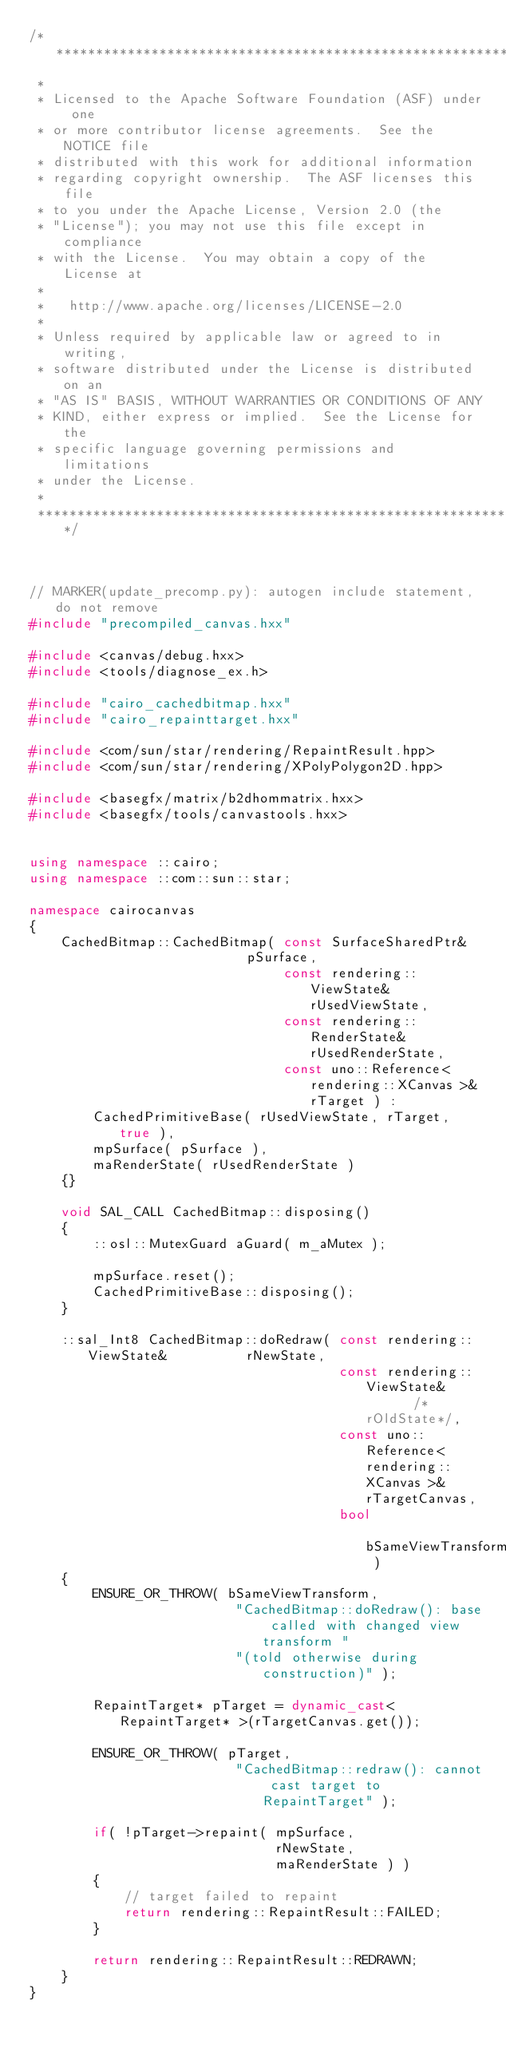Convert code to text. <code><loc_0><loc_0><loc_500><loc_500><_C++_>/**************************************************************
 * 
 * Licensed to the Apache Software Foundation (ASF) under one
 * or more contributor license agreements.  See the NOTICE file
 * distributed with this work for additional information
 * regarding copyright ownership.  The ASF licenses this file
 * to you under the Apache License, Version 2.0 (the
 * "License"); you may not use this file except in compliance
 * with the License.  You may obtain a copy of the License at
 * 
 *   http://www.apache.org/licenses/LICENSE-2.0
 * 
 * Unless required by applicable law or agreed to in writing,
 * software distributed under the License is distributed on an
 * "AS IS" BASIS, WITHOUT WARRANTIES OR CONDITIONS OF ANY
 * KIND, either express or implied.  See the License for the
 * specific language governing permissions and limitations
 * under the License.
 * 
 *************************************************************/



// MARKER(update_precomp.py): autogen include statement, do not remove
#include "precompiled_canvas.hxx"

#include <canvas/debug.hxx>
#include <tools/diagnose_ex.h>

#include "cairo_cachedbitmap.hxx"
#include "cairo_repainttarget.hxx"

#include <com/sun/star/rendering/RepaintResult.hpp>
#include <com/sun/star/rendering/XPolyPolygon2D.hpp>

#include <basegfx/matrix/b2dhommatrix.hxx>
#include <basegfx/tools/canvastools.hxx>


using namespace ::cairo;
using namespace ::com::sun::star;

namespace cairocanvas
{
    CachedBitmap::CachedBitmap( const SurfaceSharedPtr&                     pSurface,
                                const rendering::ViewState&	  				rUsedViewState,
                                const rendering::RenderState&	  			rUsedRenderState,
                                const uno::Reference< rendering::XCanvas >& rTarget ) :
        CachedPrimitiveBase( rUsedViewState, rTarget, true ),
        mpSurface( pSurface ),
        maRenderState( rUsedRenderState )
    {}

    void SAL_CALL CachedBitmap::disposing()
    {
        ::osl::MutexGuard aGuard( m_aMutex );

        mpSurface.reset();
        CachedPrimitiveBase::disposing();
    }

    ::sal_Int8 CachedBitmap::doRedraw( const rendering::ViewState&					rNewState,
                                       const rendering::ViewState&					/*rOldState*/,
                                       const uno::Reference< rendering::XCanvas >& 	rTargetCanvas,
                                       bool											bSameViewTransform )
    {
        ENSURE_OR_THROW( bSameViewTransform,
                          "CachedBitmap::doRedraw(): base called with changed view transform "
                          "(told otherwise during construction)" );

        RepaintTarget* pTarget = dynamic_cast< RepaintTarget* >(rTargetCanvas.get());

        ENSURE_OR_THROW( pTarget,
                          "CachedBitmap::redraw(): cannot cast target to RepaintTarget" );

        if( !pTarget->repaint( mpSurface,
                               rNewState,
                               maRenderState ) )
        {
            // target failed to repaint
            return rendering::RepaintResult::FAILED;
        }

        return rendering::RepaintResult::REDRAWN;
    }
}
</code> 